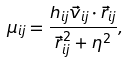<formula> <loc_0><loc_0><loc_500><loc_500>\mu _ { i j } = \frac { h _ { i j } \vec { v } _ { i j } \cdot \vec { r } _ { i j } } { \vec { r } _ { i j } ^ { 2 } + \eta ^ { 2 } } ,</formula> 